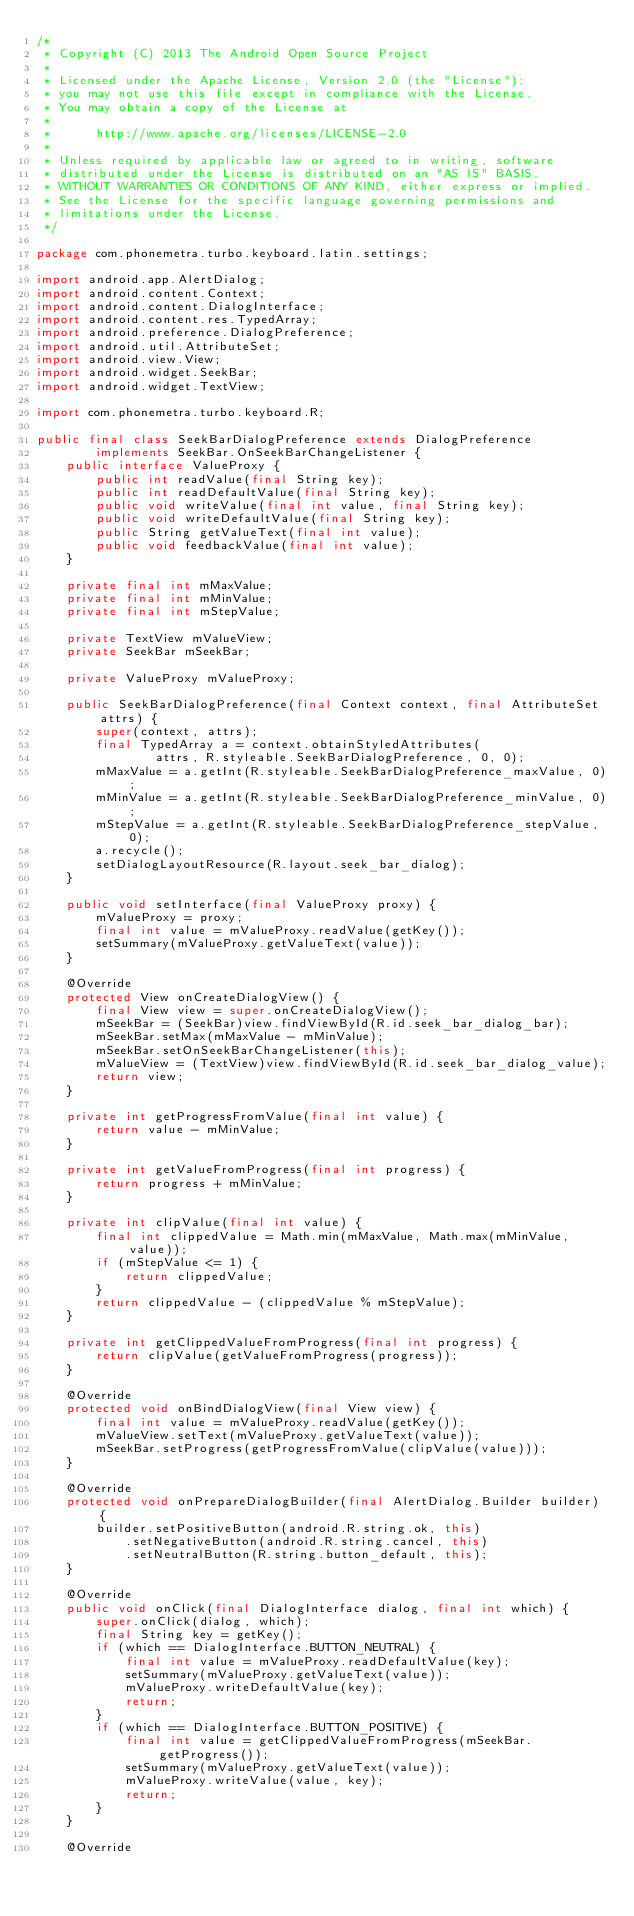<code> <loc_0><loc_0><loc_500><loc_500><_Java_>/*
 * Copyright (C) 2013 The Android Open Source Project
 *
 * Licensed under the Apache License, Version 2.0 (the "License");
 * you may not use this file except in compliance with the License.
 * You may obtain a copy of the License at
 *
 *      http://www.apache.org/licenses/LICENSE-2.0
 *
 * Unless required by applicable law or agreed to in writing, software
 * distributed under the License is distributed on an "AS IS" BASIS,
 * WITHOUT WARRANTIES OR CONDITIONS OF ANY KIND, either express or implied.
 * See the License for the specific language governing permissions and
 * limitations under the License.
 */

package com.phonemetra.turbo.keyboard.latin.settings;

import android.app.AlertDialog;
import android.content.Context;
import android.content.DialogInterface;
import android.content.res.TypedArray;
import android.preference.DialogPreference;
import android.util.AttributeSet;
import android.view.View;
import android.widget.SeekBar;
import android.widget.TextView;

import com.phonemetra.turbo.keyboard.R;

public final class SeekBarDialogPreference extends DialogPreference
        implements SeekBar.OnSeekBarChangeListener {
    public interface ValueProxy {
        public int readValue(final String key);
        public int readDefaultValue(final String key);
        public void writeValue(final int value, final String key);
        public void writeDefaultValue(final String key);
        public String getValueText(final int value);
        public void feedbackValue(final int value);
    }

    private final int mMaxValue;
    private final int mMinValue;
    private final int mStepValue;

    private TextView mValueView;
    private SeekBar mSeekBar;

    private ValueProxy mValueProxy;

    public SeekBarDialogPreference(final Context context, final AttributeSet attrs) {
        super(context, attrs);
        final TypedArray a = context.obtainStyledAttributes(
                attrs, R.styleable.SeekBarDialogPreference, 0, 0);
        mMaxValue = a.getInt(R.styleable.SeekBarDialogPreference_maxValue, 0);
        mMinValue = a.getInt(R.styleable.SeekBarDialogPreference_minValue, 0);
        mStepValue = a.getInt(R.styleable.SeekBarDialogPreference_stepValue, 0);
        a.recycle();
        setDialogLayoutResource(R.layout.seek_bar_dialog);
    }

    public void setInterface(final ValueProxy proxy) {
        mValueProxy = proxy;
        final int value = mValueProxy.readValue(getKey());
        setSummary(mValueProxy.getValueText(value));
    }

    @Override
    protected View onCreateDialogView() {
        final View view = super.onCreateDialogView();
        mSeekBar = (SeekBar)view.findViewById(R.id.seek_bar_dialog_bar);
        mSeekBar.setMax(mMaxValue - mMinValue);
        mSeekBar.setOnSeekBarChangeListener(this);
        mValueView = (TextView)view.findViewById(R.id.seek_bar_dialog_value);
        return view;
    }

    private int getProgressFromValue(final int value) {
        return value - mMinValue;
    }

    private int getValueFromProgress(final int progress) {
        return progress + mMinValue;
    }

    private int clipValue(final int value) {
        final int clippedValue = Math.min(mMaxValue, Math.max(mMinValue, value));
        if (mStepValue <= 1) {
            return clippedValue;
        }
        return clippedValue - (clippedValue % mStepValue);
    }

    private int getClippedValueFromProgress(final int progress) {
        return clipValue(getValueFromProgress(progress));
    }

    @Override
    protected void onBindDialogView(final View view) {
        final int value = mValueProxy.readValue(getKey());
        mValueView.setText(mValueProxy.getValueText(value));
        mSeekBar.setProgress(getProgressFromValue(clipValue(value)));
    }

    @Override
    protected void onPrepareDialogBuilder(final AlertDialog.Builder builder) {
        builder.setPositiveButton(android.R.string.ok, this)
            .setNegativeButton(android.R.string.cancel, this)
            .setNeutralButton(R.string.button_default, this);
    }

    @Override
    public void onClick(final DialogInterface dialog, final int which) {
        super.onClick(dialog, which);
        final String key = getKey();
        if (which == DialogInterface.BUTTON_NEUTRAL) {
            final int value = mValueProxy.readDefaultValue(key);
            setSummary(mValueProxy.getValueText(value));
            mValueProxy.writeDefaultValue(key);
            return;
        }
        if (which == DialogInterface.BUTTON_POSITIVE) {
            final int value = getClippedValueFromProgress(mSeekBar.getProgress());
            setSummary(mValueProxy.getValueText(value));
            mValueProxy.writeValue(value, key);
            return;
        }
    }

    @Override</code> 